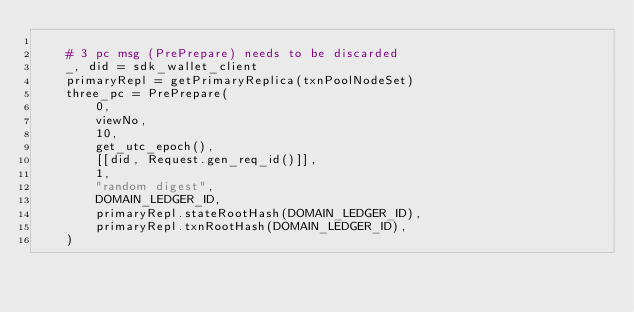<code> <loc_0><loc_0><loc_500><loc_500><_Python_>
    # 3 pc msg (PrePrepare) needs to be discarded
    _, did = sdk_wallet_client
    primaryRepl = getPrimaryReplica(txnPoolNodeSet)
    three_pc = PrePrepare(
        0,
        viewNo,
        10,
        get_utc_epoch(),
        [[did, Request.gen_req_id()]],
        1,
        "random digest",
        DOMAIN_LEDGER_ID,
        primaryRepl.stateRootHash(DOMAIN_LEDGER_ID),
        primaryRepl.txnRootHash(DOMAIN_LEDGER_ID),
    )</code> 